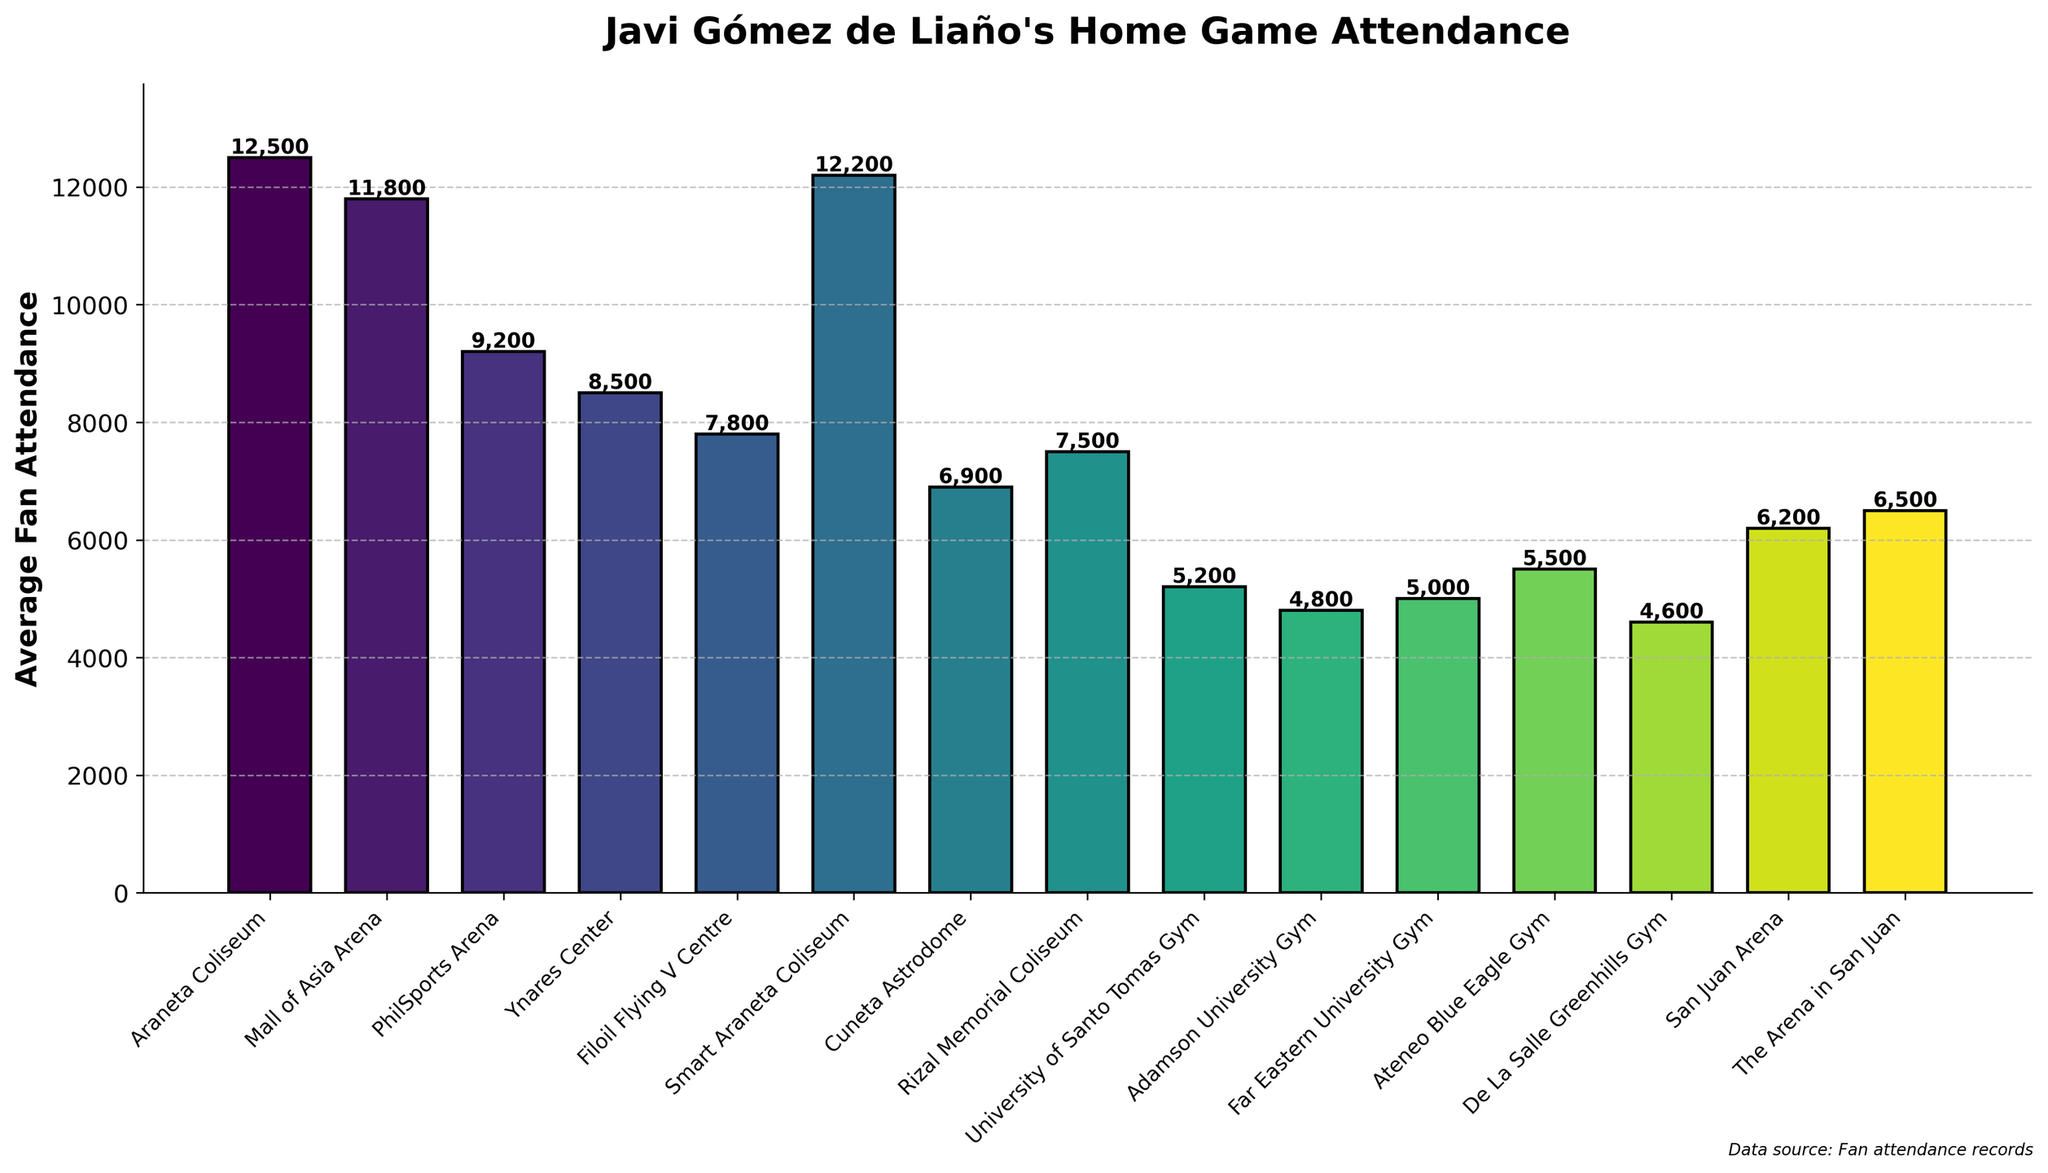What is the venue with the highest average fan attendance? The bar representing Araneta Coliseum has the highest height among all the bars in the chart, indicating it has the highest average fan attendance.
Answer: Araneta Coliseum Which venues have an average fan attendance greater than 10,000? Observing the heights of the bars, Araneta Coliseum, Smart Araneta Coliseum, and Mall of Asia Arena are the only venues with bar heights that exceed the 10,000 mark on the y-axis.
Answer: Araneta Coliseum, Smart Araneta Coliseum, Mall of Asia Arena Among the bottom three venues, which one has the highest average fan attendance? By looking at the heights of the bars for the bottom three venues (De La Salle Greenhills Gym, Adamson University Gym, and Far Eastern University Gym), the Far Eastern University Gym has the highest height among them.
Answer: Far Eastern University Gym What is the difference in average fan attendance between the venue with the highest and the lowest attendance? Araneta Coliseum has the highest attendance of 12,500, and De La Salle Greenhills Gym has the lowest attendance of 4,600. Subtracting the lowest from the highest gives 12,500 - 4,600.
Answer: 7,900 What's the average fan attendance across all venues? Summing all the average fan sessions: 12500 + 11800 + 9200 + 8500 + 7800 + 12200 + 6900 + 7500 + 5200 + 4800 + 5000 + 5500 + 4600 + 6200 + 6500, which gives 121200. There are 15 venues, so dividing 121200 by 15.
Answer: 8,080 Which venue is closest in average fan attendance to the PhilSports Arena? PhilSports Arena has an attendance of 9,200. The venues with similar attendance are Smart Araneta Coliseum (12,200) and Ynares Center (8,500), but Ynares Center is closer in value.
Answer: Ynares Center How much higher is the average fan attendance at Araneta Coliseum compared to the Smart Araneta Coliseum? Araneta Coliseum has an attendance of 12,500, while Smart Araneta Coliseum has 12,200. The difference is 12,500 - 12,200.
Answer: 300 Which venues have an average fan attendance below 6,000? By checking the height and reading the values, the venues below the 6,000 mark are: University of Santo Tomas Gym (5,200), Adamson University Gym (4,800), Far Eastern University Gym (5,000), and De La Salle Greenhills Gym (4,600).
Answer: University of Santo Tomas Gym, Adamson University Gym, Far Eastern University Gym, De La Salle Greenhills Gym Is the average fan attendance at the San Juan Arena higher or lower than at the Rizal Memorial Coliseum? San Juan Arena has an attendance of 6,200, while Rizal Memorial Coliseum has 7,500. Comparing these two values, 6,200 < 7,500.
Answer: Lower 